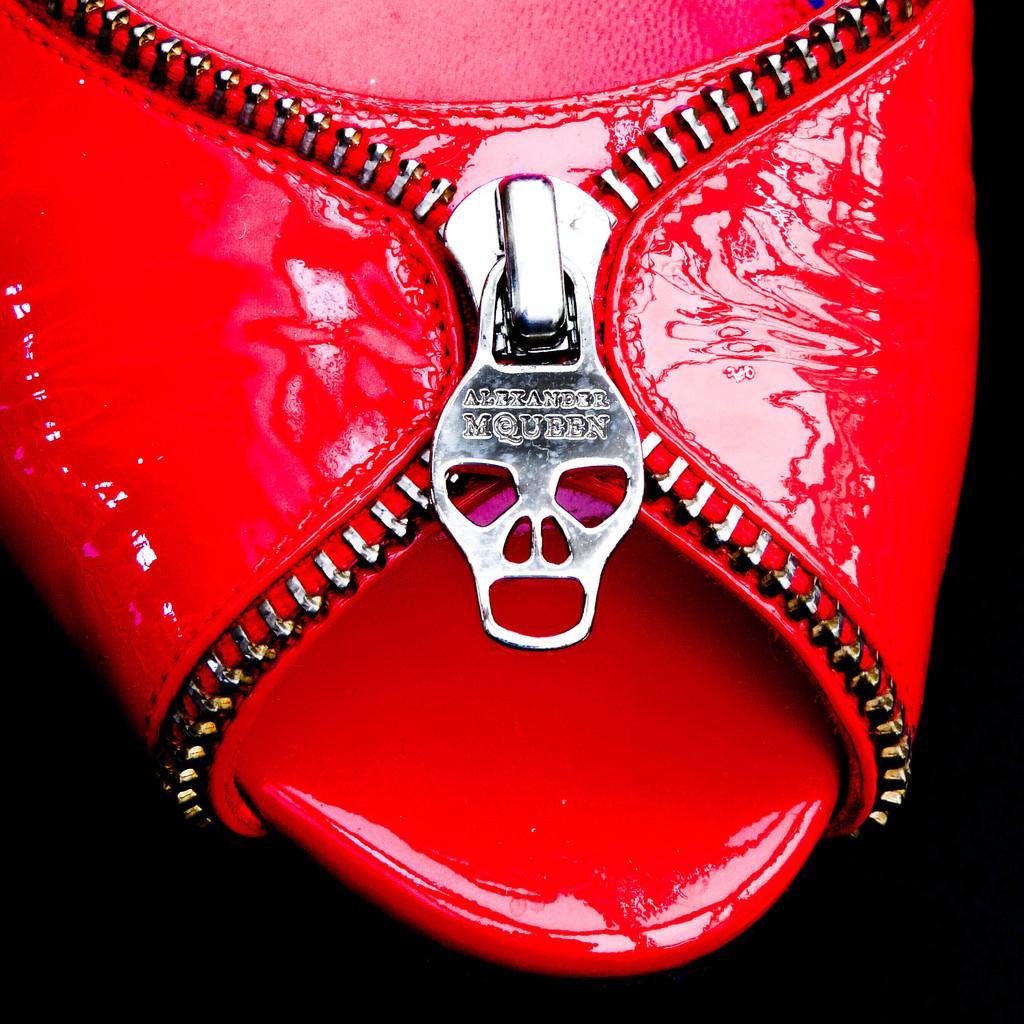How would you summarize this image in a sentence or two? In this image we can see a footwear, which is in red color. 